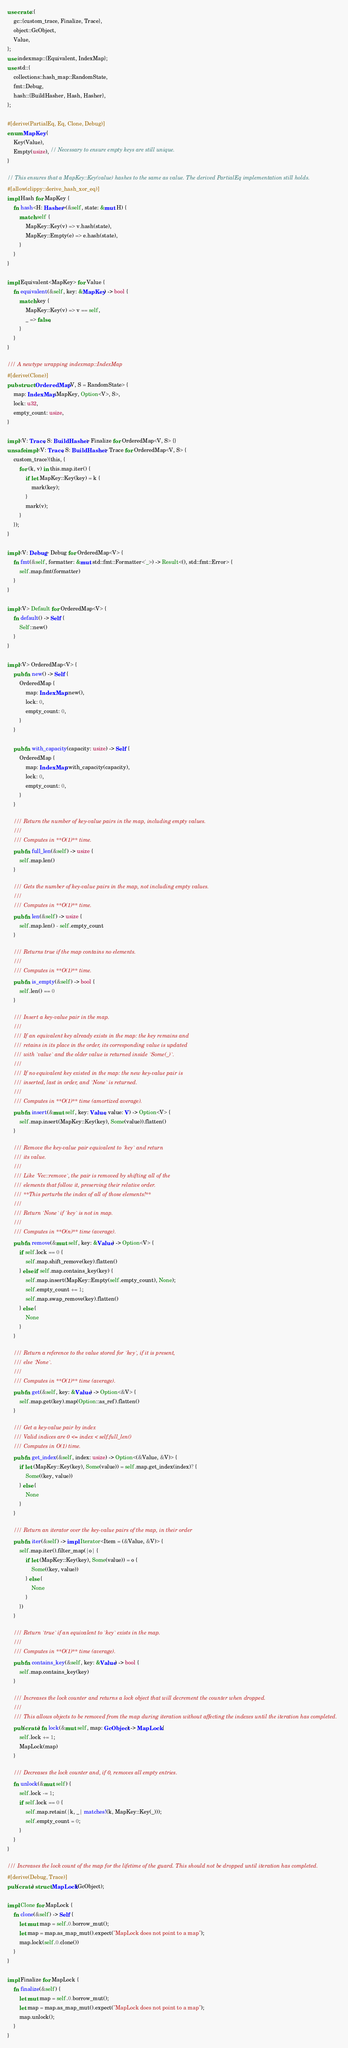<code> <loc_0><loc_0><loc_500><loc_500><_Rust_>use crate::{
    gc::{custom_trace, Finalize, Trace},
    object::GcObject,
    Value,
};
use indexmap::{Equivalent, IndexMap};
use std::{
    collections::hash_map::RandomState,
    fmt::Debug,
    hash::{BuildHasher, Hash, Hasher},
};

#[derive(PartialEq, Eq, Clone, Debug)]
enum MapKey {
    Key(Value),
    Empty(usize), // Necessary to ensure empty keys are still unique.
}

// This ensures that a MapKey::Key(value) hashes to the same as value. The derived PartialEq implementation still holds.
#[allow(clippy::derive_hash_xor_eq)]
impl Hash for MapKey {
    fn hash<H: Hasher>(&self, state: &mut H) {
        match self {
            MapKey::Key(v) => v.hash(state),
            MapKey::Empty(e) => e.hash(state),
        }
    }
}

impl Equivalent<MapKey> for Value {
    fn equivalent(&self, key: &MapKey) -> bool {
        match key {
            MapKey::Key(v) => v == self,
            _ => false,
        }
    }
}

/// A newtype wrapping indexmap::IndexMap
#[derive(Clone)]
pub struct OrderedMap<V, S = RandomState> {
    map: IndexMap<MapKey, Option<V>, S>,
    lock: u32,
    empty_count: usize,
}

impl<V: Trace, S: BuildHasher> Finalize for OrderedMap<V, S> {}
unsafe impl<V: Trace, S: BuildHasher> Trace for OrderedMap<V, S> {
    custom_trace!(this, {
        for (k, v) in this.map.iter() {
            if let MapKey::Key(key) = k {
                mark(key);
            }
            mark(v);
        }
    });
}

impl<V: Debug> Debug for OrderedMap<V> {
    fn fmt(&self, formatter: &mut std::fmt::Formatter<'_>) -> Result<(), std::fmt::Error> {
        self.map.fmt(formatter)
    }
}

impl<V> Default for OrderedMap<V> {
    fn default() -> Self {
        Self::new()
    }
}

impl<V> OrderedMap<V> {
    pub fn new() -> Self {
        OrderedMap {
            map: IndexMap::new(),
            lock: 0,
            empty_count: 0,
        }
    }

    pub fn with_capacity(capacity: usize) -> Self {
        OrderedMap {
            map: IndexMap::with_capacity(capacity),
            lock: 0,
            empty_count: 0,
        }
    }

    /// Return the number of key-value pairs in the map, including empty values.
    ///
    /// Computes in **O(1)** time.
    pub fn full_len(&self) -> usize {
        self.map.len()
    }

    /// Gets the number of key-value pairs in the map, not including empty values.
    ///
    /// Computes in **O(1)** time.
    pub fn len(&self) -> usize {
        self.map.len() - self.empty_count
    }

    /// Returns true if the map contains no elements.
    ///
    /// Computes in **O(1)** time.
    pub fn is_empty(&self) -> bool {
        self.len() == 0
    }

    /// Insert a key-value pair in the map.
    ///
    /// If an equivalent key already exists in the map: the key remains and
    /// retains in its place in the order, its corresponding value is updated
    /// with `value` and the older value is returned inside `Some(_)`.
    ///
    /// If no equivalent key existed in the map: the new key-value pair is
    /// inserted, last in order, and `None` is returned.
    ///
    /// Computes in **O(1)** time (amortized average).
    pub fn insert(&mut self, key: Value, value: V) -> Option<V> {
        self.map.insert(MapKey::Key(key), Some(value)).flatten()
    }

    /// Remove the key-value pair equivalent to `key` and return
    /// its value.
    ///
    /// Like `Vec::remove`, the pair is removed by shifting all of the
    /// elements that follow it, preserving their relative order.
    /// **This perturbs the index of all of those elements!**
    ///
    /// Return `None` if `key` is not in map.
    ///
    /// Computes in **O(n)** time (average).
    pub fn remove(&mut self, key: &Value) -> Option<V> {
        if self.lock == 0 {
            self.map.shift_remove(key).flatten()
        } else if self.map.contains_key(key) {
            self.map.insert(MapKey::Empty(self.empty_count), None);
            self.empty_count += 1;
            self.map.swap_remove(key).flatten()
        } else {
            None
        }
    }

    /// Return a reference to the value stored for `key`, if it is present,
    /// else `None`.
    ///
    /// Computes in **O(1)** time (average).
    pub fn get(&self, key: &Value) -> Option<&V> {
        self.map.get(key).map(Option::as_ref).flatten()
    }

    /// Get a key-value pair by index
    /// Valid indices are 0 <= index < self.full_len()
    /// Computes in O(1) time.
    pub fn get_index(&self, index: usize) -> Option<(&Value, &V)> {
        if let (MapKey::Key(key), Some(value)) = self.map.get_index(index)? {
            Some((key, value))
        } else {
            None
        }
    }

    /// Return an iterator over the key-value pairs of the map, in their order
    pub fn iter(&self) -> impl Iterator<Item = (&Value, &V)> {
        self.map.iter().filter_map(|o| {
            if let (MapKey::Key(key), Some(value)) = o {
                Some((key, value))
            } else {
                None
            }
        })
    }

    /// Return `true` if an equivalent to `key` exists in the map.
    ///
    /// Computes in **O(1)** time (average).
    pub fn contains_key(&self, key: &Value) -> bool {
        self.map.contains_key(key)
    }

    /// Increases the lock counter and returns a lock object that will decrement the counter when dropped.
    ///
    /// This allows objects to be removed from the map during iteration without affecting the indexes until the iteration has completed.
    pub(crate) fn lock(&mut self, map: GcObject) -> MapLock {
        self.lock += 1;
        MapLock(map)
    }

    /// Decreases the lock counter and, if 0, removes all empty entries.
    fn unlock(&mut self) {
        self.lock -= 1;
        if self.lock == 0 {
            self.map.retain(|k, _| matches!(k, MapKey::Key(_)));
            self.empty_count = 0;
        }
    }
}

/// Increases the lock count of the map for the lifetime of the guard. This should not be dropped until iteration has completed.
#[derive(Debug, Trace)]
pub(crate) struct MapLock(GcObject);

impl Clone for MapLock {
    fn clone(&self) -> Self {
        let mut map = self.0.borrow_mut();
        let map = map.as_map_mut().expect("MapLock does not point to a map");
        map.lock(self.0.clone())
    }
}

impl Finalize for MapLock {
    fn finalize(&self) {
        let mut map = self.0.borrow_mut();
        let map = map.as_map_mut().expect("MapLock does not point to a map");
        map.unlock();
    }
}
</code> 